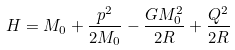Convert formula to latex. <formula><loc_0><loc_0><loc_500><loc_500>H = M _ { 0 } + \frac { p ^ { 2 } } { 2 M _ { 0 } } - \frac { G M _ { 0 } ^ { 2 } } { 2 R } + \frac { Q ^ { 2 } } { 2 R }</formula> 